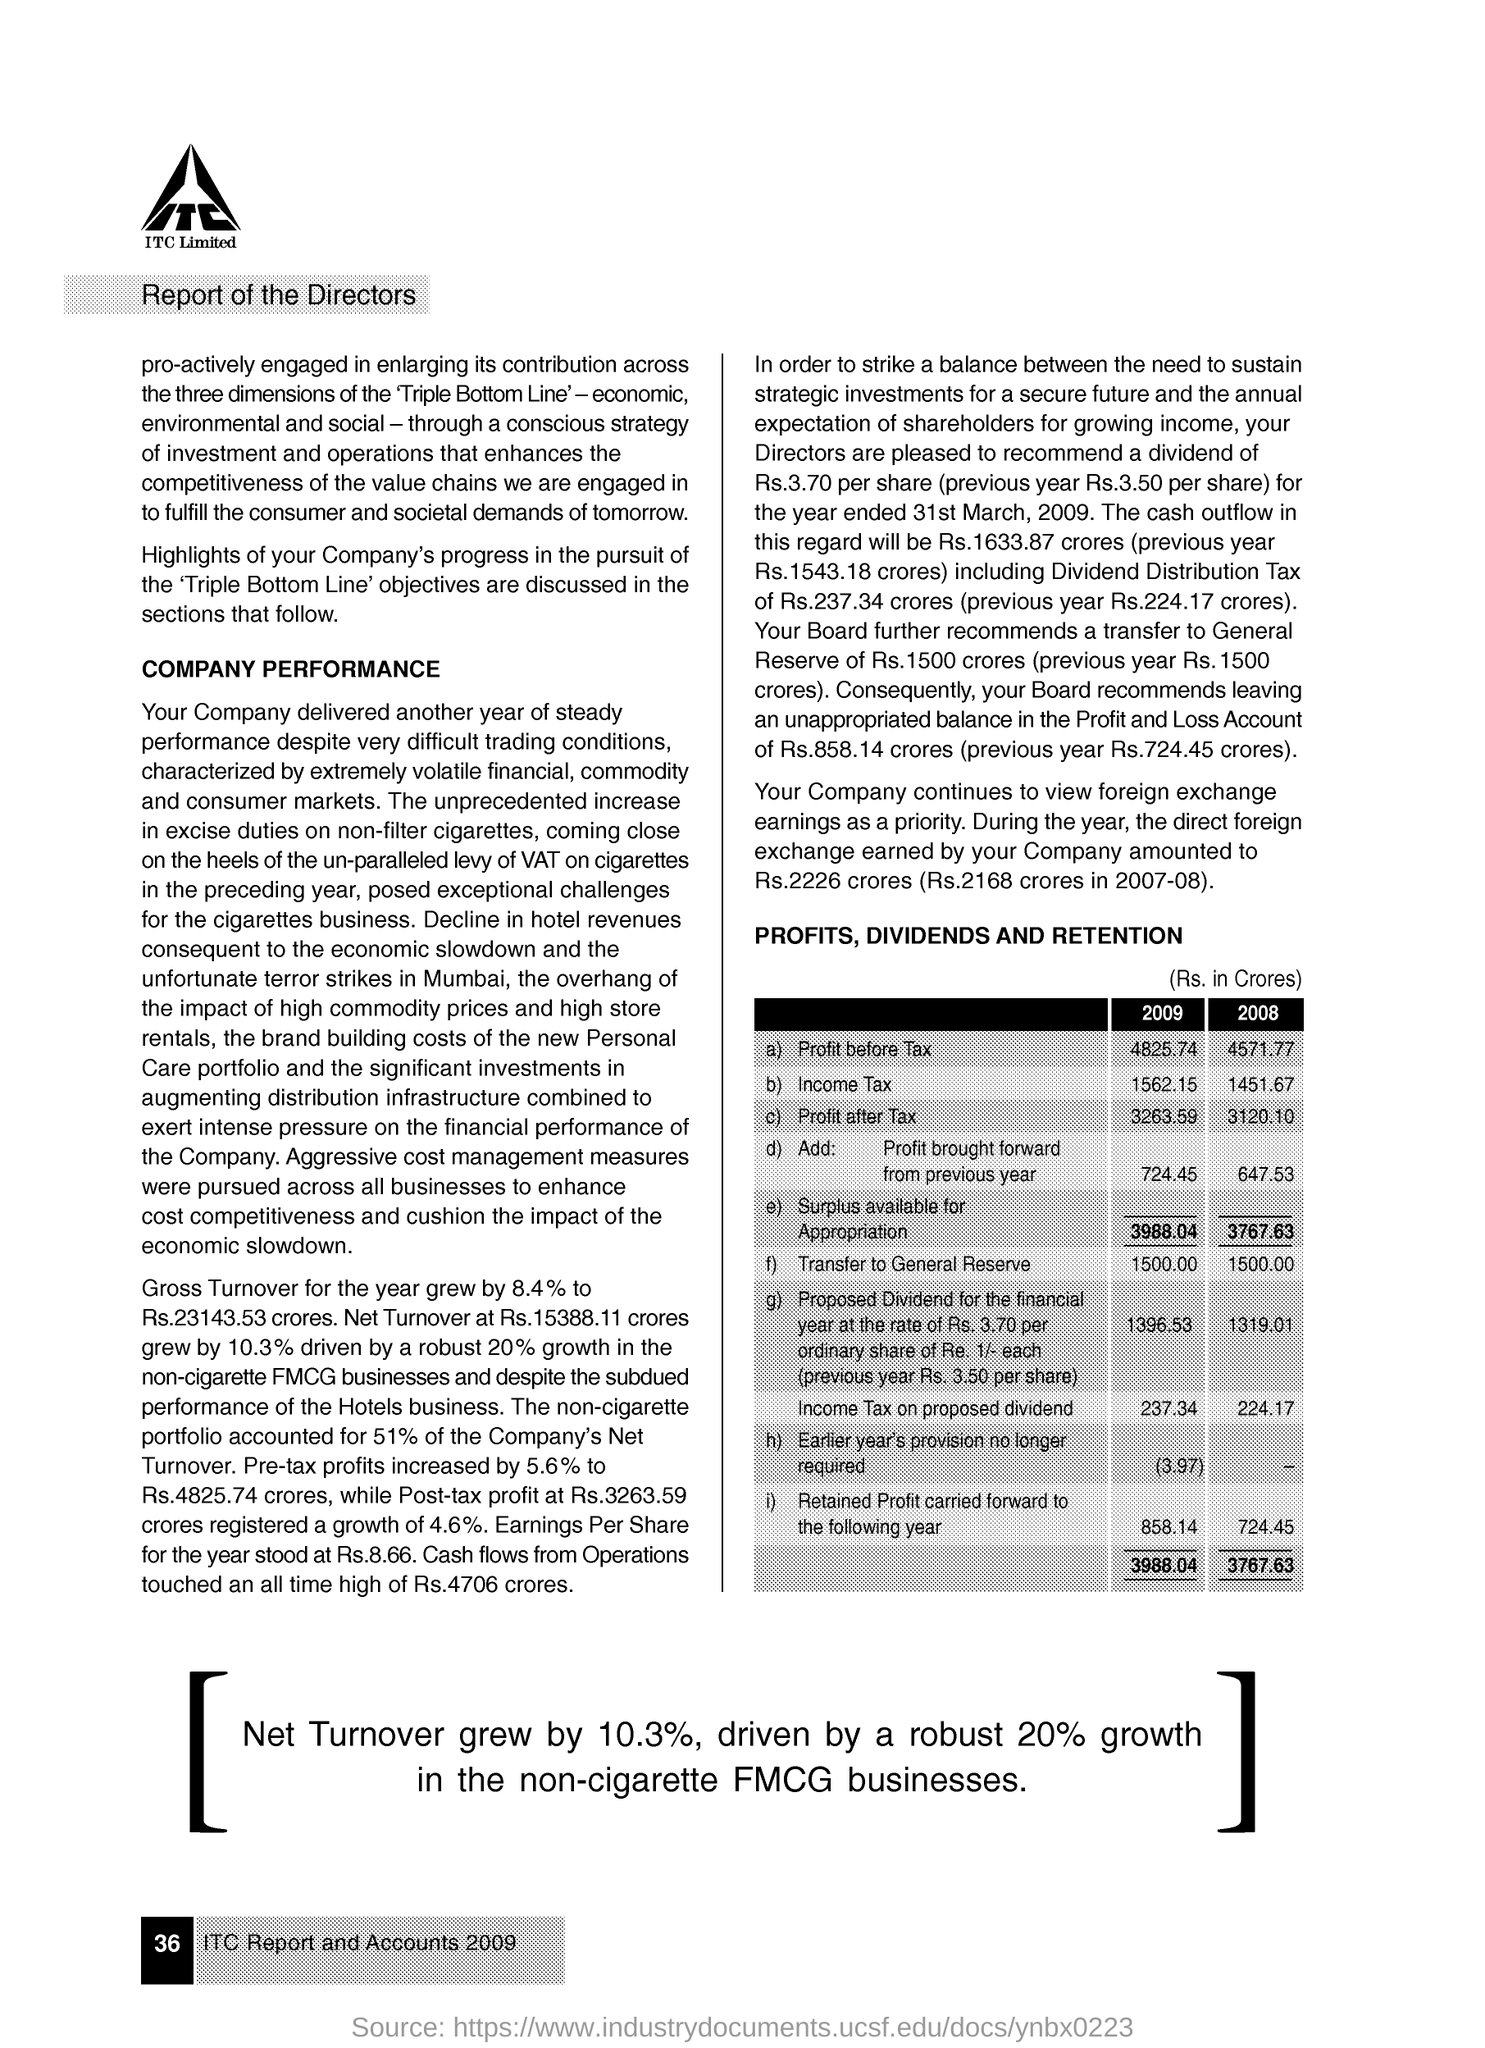Specify some key components in this picture. In the year 2008, the income tax amounted to 1451.67 dollars. The net growth in turnover was 10.3%. The profit before tax in 2009 was 4,825.74. 